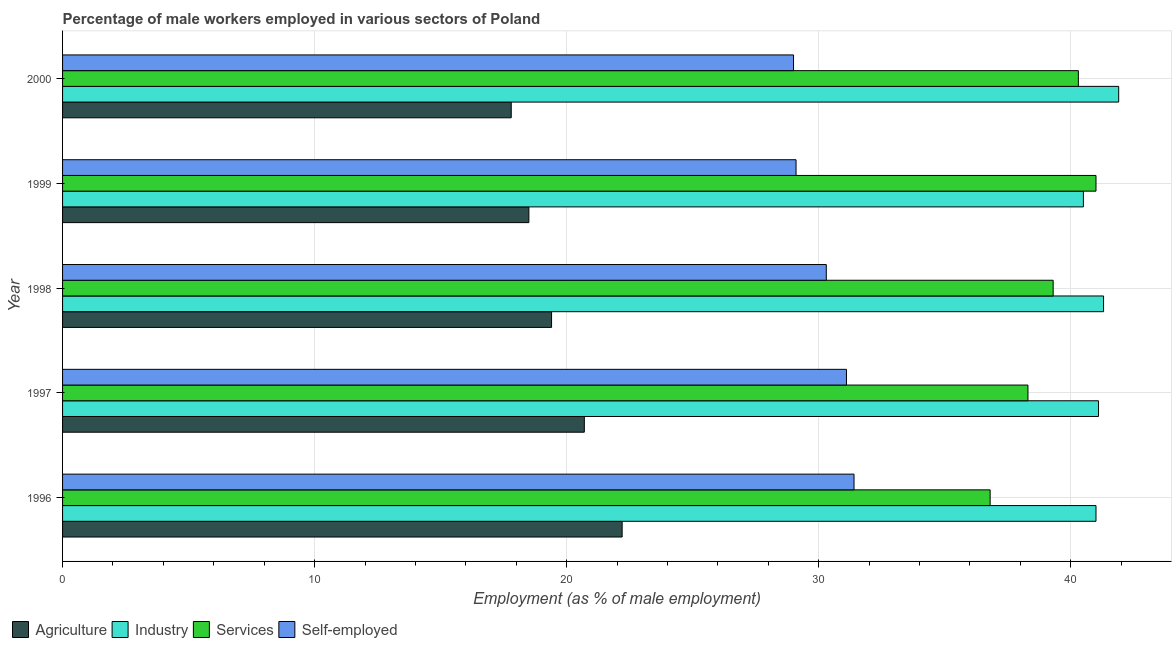How many different coloured bars are there?
Give a very brief answer. 4. How many groups of bars are there?
Offer a very short reply. 5. Are the number of bars per tick equal to the number of legend labels?
Provide a succinct answer. Yes. How many bars are there on the 3rd tick from the top?
Offer a terse response. 4. What is the label of the 3rd group of bars from the top?
Make the answer very short. 1998. In how many cases, is the number of bars for a given year not equal to the number of legend labels?
Make the answer very short. 0. What is the percentage of male workers in agriculture in 1997?
Your answer should be very brief. 20.7. Across all years, what is the maximum percentage of male workers in agriculture?
Keep it short and to the point. 22.2. Across all years, what is the minimum percentage of male workers in services?
Keep it short and to the point. 36.8. What is the total percentage of male workers in agriculture in the graph?
Your response must be concise. 98.6. What is the difference between the percentage of male workers in industry in 1996 and that in 1999?
Give a very brief answer. 0.5. What is the difference between the percentage of male workers in industry in 1996 and the percentage of male workers in services in 1998?
Give a very brief answer. 1.7. What is the average percentage of self employed male workers per year?
Offer a terse response. 30.18. In the year 1996, what is the difference between the percentage of male workers in agriculture and percentage of self employed male workers?
Ensure brevity in your answer.  -9.2. In how many years, is the percentage of male workers in services greater than 12 %?
Your response must be concise. 5. What is the ratio of the percentage of male workers in agriculture in 1996 to that in 2000?
Your answer should be very brief. 1.25. Is the percentage of self employed male workers in 1999 less than that in 2000?
Your answer should be very brief. No. Is the difference between the percentage of male workers in agriculture in 1996 and 2000 greater than the difference between the percentage of male workers in industry in 1996 and 2000?
Provide a succinct answer. Yes. What does the 1st bar from the top in 1999 represents?
Provide a succinct answer. Self-employed. What does the 3rd bar from the bottom in 1997 represents?
Ensure brevity in your answer.  Services. Is it the case that in every year, the sum of the percentage of male workers in agriculture and percentage of male workers in industry is greater than the percentage of male workers in services?
Give a very brief answer. Yes. Are all the bars in the graph horizontal?
Give a very brief answer. Yes. Does the graph contain any zero values?
Your answer should be compact. No. Does the graph contain grids?
Offer a very short reply. Yes. What is the title of the graph?
Offer a terse response. Percentage of male workers employed in various sectors of Poland. What is the label or title of the X-axis?
Give a very brief answer. Employment (as % of male employment). What is the Employment (as % of male employment) of Agriculture in 1996?
Keep it short and to the point. 22.2. What is the Employment (as % of male employment) in Industry in 1996?
Provide a short and direct response. 41. What is the Employment (as % of male employment) of Services in 1996?
Provide a short and direct response. 36.8. What is the Employment (as % of male employment) of Self-employed in 1996?
Your answer should be compact. 31.4. What is the Employment (as % of male employment) of Agriculture in 1997?
Give a very brief answer. 20.7. What is the Employment (as % of male employment) of Industry in 1997?
Provide a short and direct response. 41.1. What is the Employment (as % of male employment) of Services in 1997?
Offer a very short reply. 38.3. What is the Employment (as % of male employment) in Self-employed in 1997?
Make the answer very short. 31.1. What is the Employment (as % of male employment) in Agriculture in 1998?
Give a very brief answer. 19.4. What is the Employment (as % of male employment) in Industry in 1998?
Your answer should be compact. 41.3. What is the Employment (as % of male employment) in Services in 1998?
Keep it short and to the point. 39.3. What is the Employment (as % of male employment) of Self-employed in 1998?
Provide a short and direct response. 30.3. What is the Employment (as % of male employment) of Agriculture in 1999?
Provide a short and direct response. 18.5. What is the Employment (as % of male employment) of Industry in 1999?
Offer a terse response. 40.5. What is the Employment (as % of male employment) in Services in 1999?
Your answer should be compact. 41. What is the Employment (as % of male employment) of Self-employed in 1999?
Make the answer very short. 29.1. What is the Employment (as % of male employment) in Agriculture in 2000?
Give a very brief answer. 17.8. What is the Employment (as % of male employment) of Industry in 2000?
Give a very brief answer. 41.9. What is the Employment (as % of male employment) in Services in 2000?
Your response must be concise. 40.3. What is the Employment (as % of male employment) in Self-employed in 2000?
Give a very brief answer. 29. Across all years, what is the maximum Employment (as % of male employment) of Agriculture?
Your answer should be compact. 22.2. Across all years, what is the maximum Employment (as % of male employment) of Industry?
Offer a terse response. 41.9. Across all years, what is the maximum Employment (as % of male employment) in Services?
Offer a very short reply. 41. Across all years, what is the maximum Employment (as % of male employment) of Self-employed?
Keep it short and to the point. 31.4. Across all years, what is the minimum Employment (as % of male employment) in Agriculture?
Offer a terse response. 17.8. Across all years, what is the minimum Employment (as % of male employment) in Industry?
Offer a very short reply. 40.5. Across all years, what is the minimum Employment (as % of male employment) in Services?
Make the answer very short. 36.8. What is the total Employment (as % of male employment) of Agriculture in the graph?
Provide a short and direct response. 98.6. What is the total Employment (as % of male employment) in Industry in the graph?
Make the answer very short. 205.8. What is the total Employment (as % of male employment) in Services in the graph?
Make the answer very short. 195.7. What is the total Employment (as % of male employment) in Self-employed in the graph?
Your response must be concise. 150.9. What is the difference between the Employment (as % of male employment) in Agriculture in 1996 and that in 1997?
Ensure brevity in your answer.  1.5. What is the difference between the Employment (as % of male employment) of Self-employed in 1996 and that in 1997?
Make the answer very short. 0.3. What is the difference between the Employment (as % of male employment) of Agriculture in 1996 and that in 1998?
Ensure brevity in your answer.  2.8. What is the difference between the Employment (as % of male employment) of Industry in 1996 and that in 1998?
Your answer should be very brief. -0.3. What is the difference between the Employment (as % of male employment) in Self-employed in 1996 and that in 1998?
Offer a very short reply. 1.1. What is the difference between the Employment (as % of male employment) of Agriculture in 1996 and that in 1999?
Give a very brief answer. 3.7. What is the difference between the Employment (as % of male employment) in Industry in 1996 and that in 1999?
Your response must be concise. 0.5. What is the difference between the Employment (as % of male employment) of Agriculture in 1996 and that in 2000?
Provide a succinct answer. 4.4. What is the difference between the Employment (as % of male employment) of Services in 1996 and that in 2000?
Keep it short and to the point. -3.5. What is the difference between the Employment (as % of male employment) in Self-employed in 1997 and that in 1998?
Your response must be concise. 0.8. What is the difference between the Employment (as % of male employment) of Agriculture in 1997 and that in 1999?
Make the answer very short. 2.2. What is the difference between the Employment (as % of male employment) in Services in 1997 and that in 1999?
Keep it short and to the point. -2.7. What is the difference between the Employment (as % of male employment) in Agriculture in 1997 and that in 2000?
Provide a succinct answer. 2.9. What is the difference between the Employment (as % of male employment) of Services in 1998 and that in 1999?
Keep it short and to the point. -1.7. What is the difference between the Employment (as % of male employment) in Agriculture in 1998 and that in 2000?
Your response must be concise. 1.6. What is the difference between the Employment (as % of male employment) in Industry in 1998 and that in 2000?
Offer a terse response. -0.6. What is the difference between the Employment (as % of male employment) of Services in 1999 and that in 2000?
Make the answer very short. 0.7. What is the difference between the Employment (as % of male employment) in Self-employed in 1999 and that in 2000?
Your response must be concise. 0.1. What is the difference between the Employment (as % of male employment) of Agriculture in 1996 and the Employment (as % of male employment) of Industry in 1997?
Make the answer very short. -18.9. What is the difference between the Employment (as % of male employment) of Agriculture in 1996 and the Employment (as % of male employment) of Services in 1997?
Keep it short and to the point. -16.1. What is the difference between the Employment (as % of male employment) in Agriculture in 1996 and the Employment (as % of male employment) in Self-employed in 1997?
Make the answer very short. -8.9. What is the difference between the Employment (as % of male employment) of Industry in 1996 and the Employment (as % of male employment) of Services in 1997?
Give a very brief answer. 2.7. What is the difference between the Employment (as % of male employment) of Services in 1996 and the Employment (as % of male employment) of Self-employed in 1997?
Your answer should be compact. 5.7. What is the difference between the Employment (as % of male employment) in Agriculture in 1996 and the Employment (as % of male employment) in Industry in 1998?
Ensure brevity in your answer.  -19.1. What is the difference between the Employment (as % of male employment) of Agriculture in 1996 and the Employment (as % of male employment) of Services in 1998?
Your response must be concise. -17.1. What is the difference between the Employment (as % of male employment) in Industry in 1996 and the Employment (as % of male employment) in Services in 1998?
Ensure brevity in your answer.  1.7. What is the difference between the Employment (as % of male employment) of Industry in 1996 and the Employment (as % of male employment) of Self-employed in 1998?
Give a very brief answer. 10.7. What is the difference between the Employment (as % of male employment) in Agriculture in 1996 and the Employment (as % of male employment) in Industry in 1999?
Provide a succinct answer. -18.3. What is the difference between the Employment (as % of male employment) of Agriculture in 1996 and the Employment (as % of male employment) of Services in 1999?
Make the answer very short. -18.8. What is the difference between the Employment (as % of male employment) of Agriculture in 1996 and the Employment (as % of male employment) of Self-employed in 1999?
Provide a short and direct response. -6.9. What is the difference between the Employment (as % of male employment) in Industry in 1996 and the Employment (as % of male employment) in Services in 1999?
Offer a terse response. 0. What is the difference between the Employment (as % of male employment) of Agriculture in 1996 and the Employment (as % of male employment) of Industry in 2000?
Make the answer very short. -19.7. What is the difference between the Employment (as % of male employment) in Agriculture in 1996 and the Employment (as % of male employment) in Services in 2000?
Give a very brief answer. -18.1. What is the difference between the Employment (as % of male employment) in Agriculture in 1996 and the Employment (as % of male employment) in Self-employed in 2000?
Offer a terse response. -6.8. What is the difference between the Employment (as % of male employment) of Industry in 1996 and the Employment (as % of male employment) of Services in 2000?
Your answer should be very brief. 0.7. What is the difference between the Employment (as % of male employment) of Services in 1996 and the Employment (as % of male employment) of Self-employed in 2000?
Provide a short and direct response. 7.8. What is the difference between the Employment (as % of male employment) in Agriculture in 1997 and the Employment (as % of male employment) in Industry in 1998?
Offer a terse response. -20.6. What is the difference between the Employment (as % of male employment) in Agriculture in 1997 and the Employment (as % of male employment) in Services in 1998?
Provide a short and direct response. -18.6. What is the difference between the Employment (as % of male employment) in Industry in 1997 and the Employment (as % of male employment) in Services in 1998?
Give a very brief answer. 1.8. What is the difference between the Employment (as % of male employment) in Agriculture in 1997 and the Employment (as % of male employment) in Industry in 1999?
Give a very brief answer. -19.8. What is the difference between the Employment (as % of male employment) in Agriculture in 1997 and the Employment (as % of male employment) in Services in 1999?
Your answer should be very brief. -20.3. What is the difference between the Employment (as % of male employment) in Agriculture in 1997 and the Employment (as % of male employment) in Self-employed in 1999?
Provide a succinct answer. -8.4. What is the difference between the Employment (as % of male employment) of Services in 1997 and the Employment (as % of male employment) of Self-employed in 1999?
Provide a short and direct response. 9.2. What is the difference between the Employment (as % of male employment) of Agriculture in 1997 and the Employment (as % of male employment) of Industry in 2000?
Your answer should be compact. -21.2. What is the difference between the Employment (as % of male employment) of Agriculture in 1997 and the Employment (as % of male employment) of Services in 2000?
Offer a very short reply. -19.6. What is the difference between the Employment (as % of male employment) of Industry in 1997 and the Employment (as % of male employment) of Self-employed in 2000?
Keep it short and to the point. 12.1. What is the difference between the Employment (as % of male employment) of Agriculture in 1998 and the Employment (as % of male employment) of Industry in 1999?
Your answer should be very brief. -21.1. What is the difference between the Employment (as % of male employment) of Agriculture in 1998 and the Employment (as % of male employment) of Services in 1999?
Give a very brief answer. -21.6. What is the difference between the Employment (as % of male employment) in Industry in 1998 and the Employment (as % of male employment) in Services in 1999?
Your answer should be compact. 0.3. What is the difference between the Employment (as % of male employment) in Services in 1998 and the Employment (as % of male employment) in Self-employed in 1999?
Offer a very short reply. 10.2. What is the difference between the Employment (as % of male employment) of Agriculture in 1998 and the Employment (as % of male employment) of Industry in 2000?
Provide a succinct answer. -22.5. What is the difference between the Employment (as % of male employment) in Agriculture in 1998 and the Employment (as % of male employment) in Services in 2000?
Provide a succinct answer. -20.9. What is the difference between the Employment (as % of male employment) in Industry in 1998 and the Employment (as % of male employment) in Services in 2000?
Your response must be concise. 1. What is the difference between the Employment (as % of male employment) in Industry in 1998 and the Employment (as % of male employment) in Self-employed in 2000?
Offer a terse response. 12.3. What is the difference between the Employment (as % of male employment) in Agriculture in 1999 and the Employment (as % of male employment) in Industry in 2000?
Keep it short and to the point. -23.4. What is the difference between the Employment (as % of male employment) of Agriculture in 1999 and the Employment (as % of male employment) of Services in 2000?
Give a very brief answer. -21.8. What is the difference between the Employment (as % of male employment) in Agriculture in 1999 and the Employment (as % of male employment) in Self-employed in 2000?
Keep it short and to the point. -10.5. What is the difference between the Employment (as % of male employment) of Industry in 1999 and the Employment (as % of male employment) of Services in 2000?
Provide a short and direct response. 0.2. What is the difference between the Employment (as % of male employment) of Industry in 1999 and the Employment (as % of male employment) of Self-employed in 2000?
Your answer should be very brief. 11.5. What is the average Employment (as % of male employment) of Agriculture per year?
Offer a very short reply. 19.72. What is the average Employment (as % of male employment) of Industry per year?
Keep it short and to the point. 41.16. What is the average Employment (as % of male employment) of Services per year?
Give a very brief answer. 39.14. What is the average Employment (as % of male employment) of Self-employed per year?
Make the answer very short. 30.18. In the year 1996, what is the difference between the Employment (as % of male employment) in Agriculture and Employment (as % of male employment) in Industry?
Provide a short and direct response. -18.8. In the year 1996, what is the difference between the Employment (as % of male employment) in Agriculture and Employment (as % of male employment) in Services?
Give a very brief answer. -14.6. In the year 1996, what is the difference between the Employment (as % of male employment) in Agriculture and Employment (as % of male employment) in Self-employed?
Offer a very short reply. -9.2. In the year 1996, what is the difference between the Employment (as % of male employment) of Services and Employment (as % of male employment) of Self-employed?
Make the answer very short. 5.4. In the year 1997, what is the difference between the Employment (as % of male employment) of Agriculture and Employment (as % of male employment) of Industry?
Offer a terse response. -20.4. In the year 1997, what is the difference between the Employment (as % of male employment) in Agriculture and Employment (as % of male employment) in Services?
Your answer should be compact. -17.6. In the year 1997, what is the difference between the Employment (as % of male employment) of Industry and Employment (as % of male employment) of Services?
Keep it short and to the point. 2.8. In the year 1997, what is the difference between the Employment (as % of male employment) of Industry and Employment (as % of male employment) of Self-employed?
Provide a succinct answer. 10. In the year 1998, what is the difference between the Employment (as % of male employment) in Agriculture and Employment (as % of male employment) in Industry?
Offer a terse response. -21.9. In the year 1998, what is the difference between the Employment (as % of male employment) in Agriculture and Employment (as % of male employment) in Services?
Your response must be concise. -19.9. In the year 1998, what is the difference between the Employment (as % of male employment) of Industry and Employment (as % of male employment) of Services?
Your response must be concise. 2. In the year 1998, what is the difference between the Employment (as % of male employment) of Services and Employment (as % of male employment) of Self-employed?
Give a very brief answer. 9. In the year 1999, what is the difference between the Employment (as % of male employment) in Agriculture and Employment (as % of male employment) in Services?
Your answer should be very brief. -22.5. In the year 1999, what is the difference between the Employment (as % of male employment) of Industry and Employment (as % of male employment) of Services?
Provide a succinct answer. -0.5. In the year 1999, what is the difference between the Employment (as % of male employment) of Industry and Employment (as % of male employment) of Self-employed?
Provide a succinct answer. 11.4. In the year 2000, what is the difference between the Employment (as % of male employment) of Agriculture and Employment (as % of male employment) of Industry?
Make the answer very short. -24.1. In the year 2000, what is the difference between the Employment (as % of male employment) in Agriculture and Employment (as % of male employment) in Services?
Ensure brevity in your answer.  -22.5. In the year 2000, what is the difference between the Employment (as % of male employment) in Agriculture and Employment (as % of male employment) in Self-employed?
Your answer should be compact. -11.2. In the year 2000, what is the difference between the Employment (as % of male employment) of Industry and Employment (as % of male employment) of Services?
Keep it short and to the point. 1.6. What is the ratio of the Employment (as % of male employment) of Agriculture in 1996 to that in 1997?
Your answer should be compact. 1.07. What is the ratio of the Employment (as % of male employment) of Services in 1996 to that in 1997?
Your answer should be compact. 0.96. What is the ratio of the Employment (as % of male employment) in Self-employed in 1996 to that in 1997?
Your answer should be very brief. 1.01. What is the ratio of the Employment (as % of male employment) in Agriculture in 1996 to that in 1998?
Ensure brevity in your answer.  1.14. What is the ratio of the Employment (as % of male employment) of Services in 1996 to that in 1998?
Give a very brief answer. 0.94. What is the ratio of the Employment (as % of male employment) in Self-employed in 1996 to that in 1998?
Offer a terse response. 1.04. What is the ratio of the Employment (as % of male employment) in Industry in 1996 to that in 1999?
Your response must be concise. 1.01. What is the ratio of the Employment (as % of male employment) in Services in 1996 to that in 1999?
Keep it short and to the point. 0.9. What is the ratio of the Employment (as % of male employment) in Self-employed in 1996 to that in 1999?
Make the answer very short. 1.08. What is the ratio of the Employment (as % of male employment) of Agriculture in 1996 to that in 2000?
Provide a succinct answer. 1.25. What is the ratio of the Employment (as % of male employment) of Industry in 1996 to that in 2000?
Offer a very short reply. 0.98. What is the ratio of the Employment (as % of male employment) of Services in 1996 to that in 2000?
Offer a very short reply. 0.91. What is the ratio of the Employment (as % of male employment) of Self-employed in 1996 to that in 2000?
Give a very brief answer. 1.08. What is the ratio of the Employment (as % of male employment) in Agriculture in 1997 to that in 1998?
Your response must be concise. 1.07. What is the ratio of the Employment (as % of male employment) in Services in 1997 to that in 1998?
Give a very brief answer. 0.97. What is the ratio of the Employment (as % of male employment) of Self-employed in 1997 to that in 1998?
Offer a terse response. 1.03. What is the ratio of the Employment (as % of male employment) of Agriculture in 1997 to that in 1999?
Your answer should be compact. 1.12. What is the ratio of the Employment (as % of male employment) in Industry in 1997 to that in 1999?
Provide a succinct answer. 1.01. What is the ratio of the Employment (as % of male employment) in Services in 1997 to that in 1999?
Offer a terse response. 0.93. What is the ratio of the Employment (as % of male employment) of Self-employed in 1997 to that in 1999?
Offer a very short reply. 1.07. What is the ratio of the Employment (as % of male employment) of Agriculture in 1997 to that in 2000?
Offer a very short reply. 1.16. What is the ratio of the Employment (as % of male employment) in Industry in 1997 to that in 2000?
Offer a very short reply. 0.98. What is the ratio of the Employment (as % of male employment) of Services in 1997 to that in 2000?
Your answer should be very brief. 0.95. What is the ratio of the Employment (as % of male employment) of Self-employed in 1997 to that in 2000?
Keep it short and to the point. 1.07. What is the ratio of the Employment (as % of male employment) of Agriculture in 1998 to that in 1999?
Keep it short and to the point. 1.05. What is the ratio of the Employment (as % of male employment) of Industry in 1998 to that in 1999?
Offer a very short reply. 1.02. What is the ratio of the Employment (as % of male employment) of Services in 1998 to that in 1999?
Offer a very short reply. 0.96. What is the ratio of the Employment (as % of male employment) of Self-employed in 1998 to that in 1999?
Your response must be concise. 1.04. What is the ratio of the Employment (as % of male employment) in Agriculture in 1998 to that in 2000?
Offer a very short reply. 1.09. What is the ratio of the Employment (as % of male employment) of Industry in 1998 to that in 2000?
Ensure brevity in your answer.  0.99. What is the ratio of the Employment (as % of male employment) of Services in 1998 to that in 2000?
Provide a succinct answer. 0.98. What is the ratio of the Employment (as % of male employment) of Self-employed in 1998 to that in 2000?
Make the answer very short. 1.04. What is the ratio of the Employment (as % of male employment) of Agriculture in 1999 to that in 2000?
Offer a very short reply. 1.04. What is the ratio of the Employment (as % of male employment) of Industry in 1999 to that in 2000?
Ensure brevity in your answer.  0.97. What is the ratio of the Employment (as % of male employment) in Services in 1999 to that in 2000?
Keep it short and to the point. 1.02. What is the difference between the highest and the second highest Employment (as % of male employment) in Self-employed?
Keep it short and to the point. 0.3. 